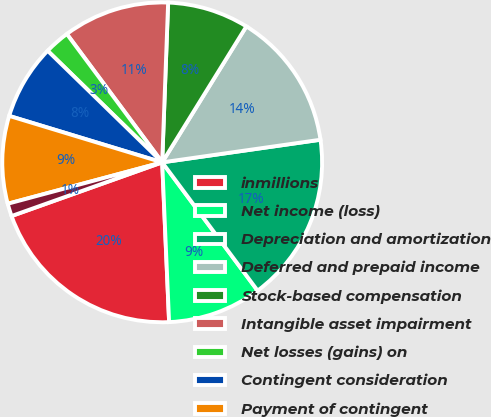Convert chart. <chart><loc_0><loc_0><loc_500><loc_500><pie_chart><fcel>inmillions<fcel>Net income (loss)<fcel>Depreciation and amortization<fcel>Deferred and prepaid income<fcel>Stock-based compensation<fcel>Intangible asset impairment<fcel>Net losses (gains) on<fcel>Contingent consideration<fcel>Payment of contingent<fcel>Other net<nl><fcel>20.24%<fcel>9.49%<fcel>17.08%<fcel>13.92%<fcel>8.23%<fcel>10.76%<fcel>2.54%<fcel>7.6%<fcel>8.86%<fcel>1.28%<nl></chart> 